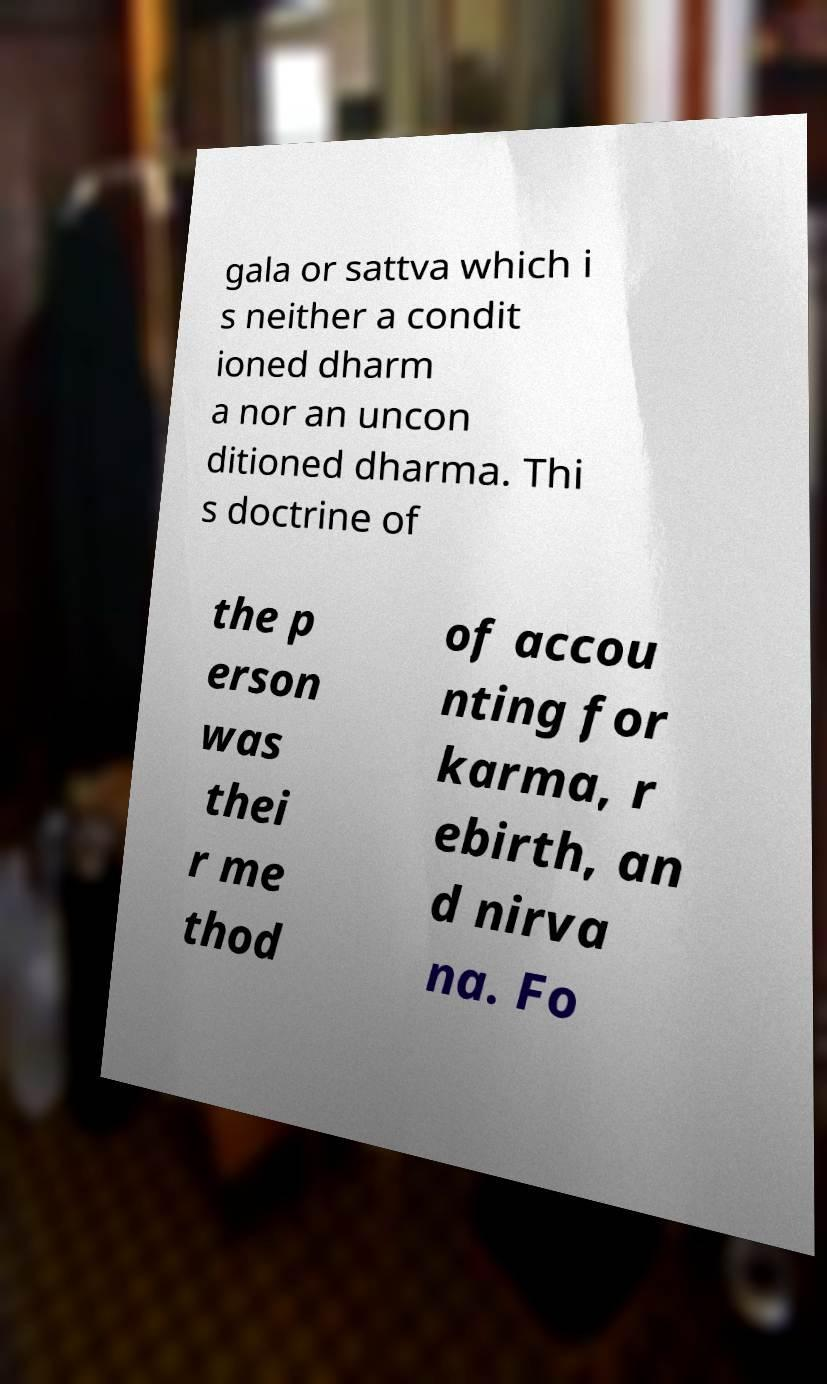Can you read and provide the text displayed in the image?This photo seems to have some interesting text. Can you extract and type it out for me? gala or sattva which i s neither a condit ioned dharm a nor an uncon ditioned dharma. Thi s doctrine of the p erson was thei r me thod of accou nting for karma, r ebirth, an d nirva na. Fo 